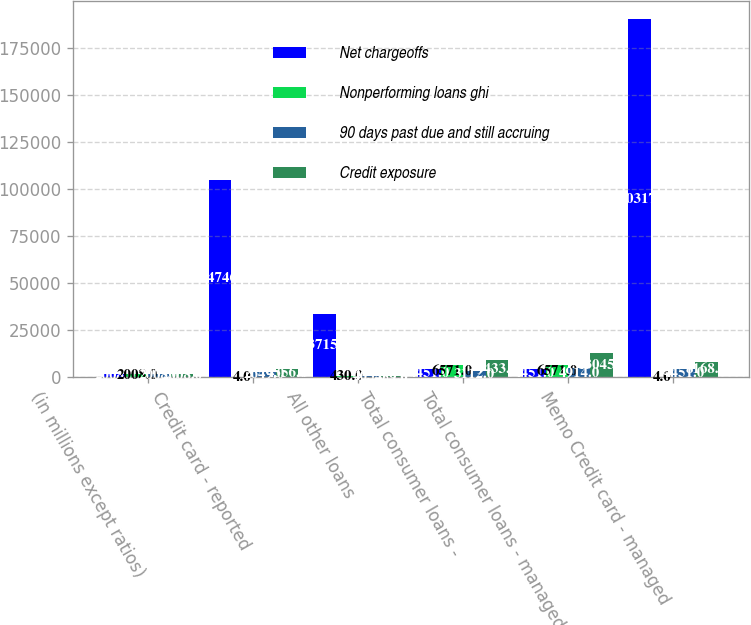Convert chart to OTSL. <chart><loc_0><loc_0><loc_500><loc_500><stacked_bar_chart><ecel><fcel>(in millions except ratios)<fcel>Credit card - reported<fcel>All other loans<fcel>Total consumer loans -<fcel>Total consumer loans - managed<fcel>Memo Credit card - managed<nl><fcel>Net chargeoffs<fcel>2008<fcel>104746<fcel>33715<fcel>4451<fcel>4451<fcel>190317<nl><fcel>Nonperforming loans ghi<fcel>2008<fcel>4<fcel>430<fcel>6571<fcel>6571<fcel>4<nl><fcel>90 days past due and still accruing<fcel>2008<fcel>2649<fcel>463<fcel>3112<fcel>4914<fcel>4451<nl><fcel>Credit exposure<fcel>2008<fcel>4556<fcel>459<fcel>9433<fcel>13045<fcel>8168<nl></chart> 